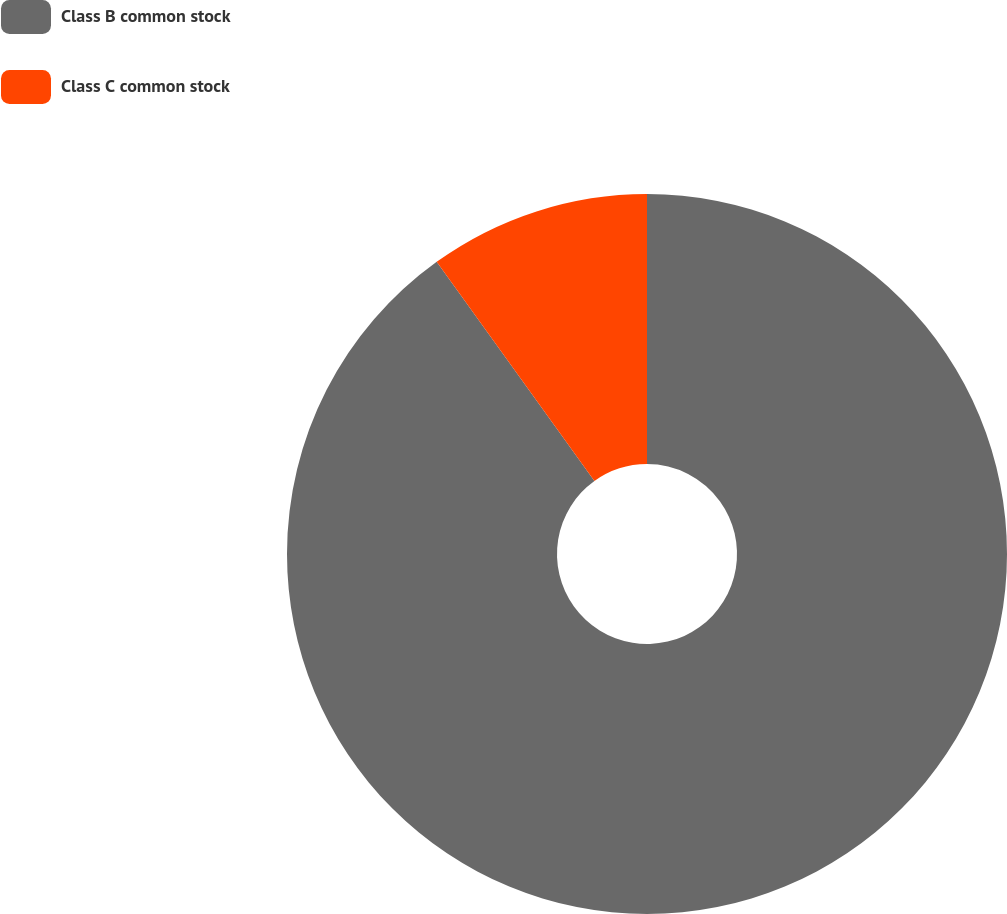Convert chart to OTSL. <chart><loc_0><loc_0><loc_500><loc_500><pie_chart><fcel>Class B common stock<fcel>Class C common stock<nl><fcel>90.07%<fcel>9.93%<nl></chart> 